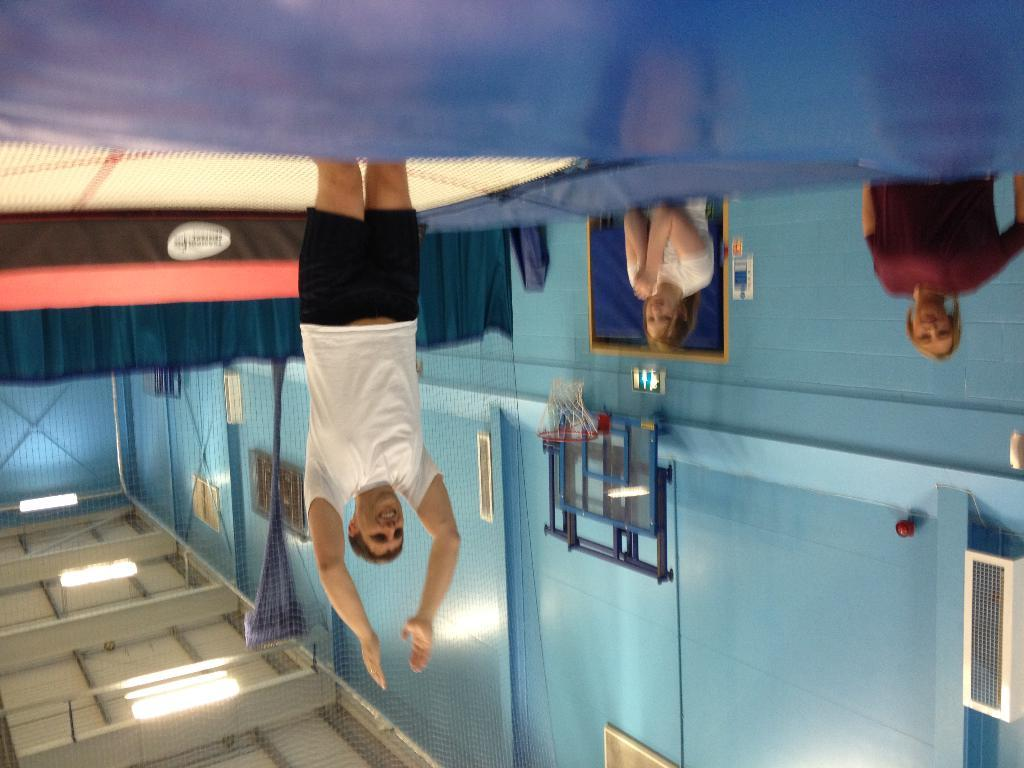What is the main subject in the image? There is a man standing in the image. What can be seen behind the man? There is a board visible in the image. What is present on the side of the image? There is a curtain in the image. What is attached to the wall in the image? There are devices on a wall in the image. What type of sports equipment is in the image? There is a basketball hoop in the image. How many women are in the image? There are two women in the image. What is the lighting source on the ceiling in the image? There is a roof with ceiling lights in the image. Where is the hen perched on the branch in the image? There is no hen or branch present in the image. What type of grain is being stored in the image? There is no grain present in the image. 